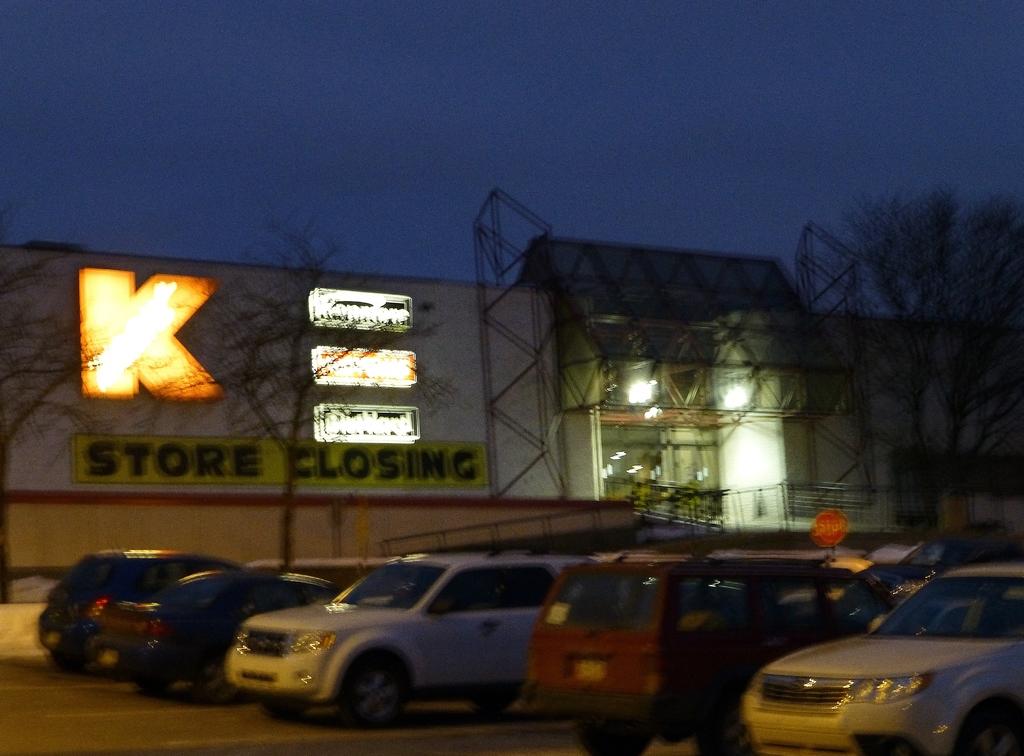What does the yellow and black sign say?
Offer a terse response. Store closing. What is happening to this store?
Offer a very short reply. Closing. 